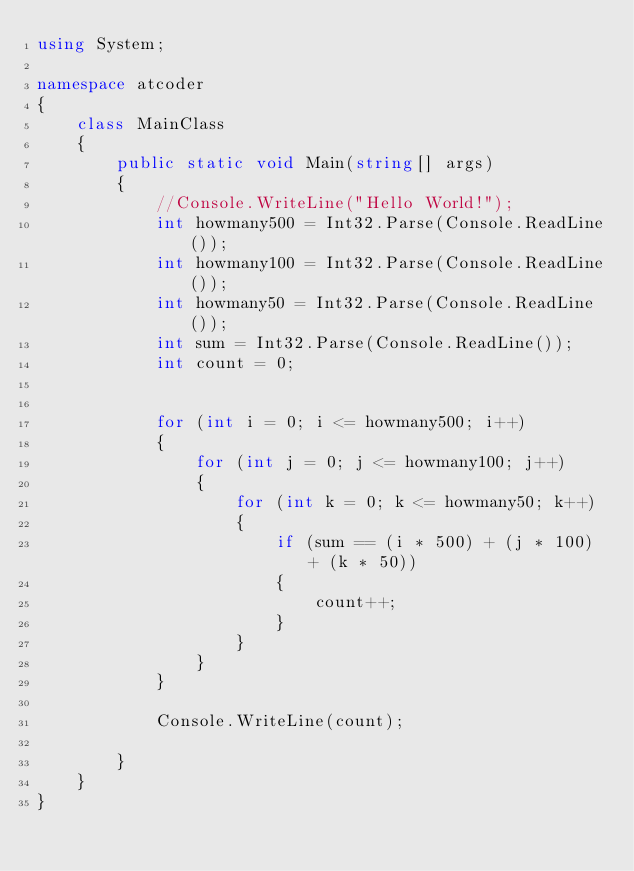<code> <loc_0><loc_0><loc_500><loc_500><_C#_>using System;

namespace atcoder
{
    class MainClass
    {
        public static void Main(string[] args)
        {
            //Console.WriteLine("Hello World!");
            int howmany500 = Int32.Parse(Console.ReadLine());
            int howmany100 = Int32.Parse(Console.ReadLine());
            int howmany50 = Int32.Parse(Console.ReadLine());
            int sum = Int32.Parse(Console.ReadLine());
            int count = 0;


            for (int i = 0; i <= howmany500; i++)
            {
                for (int j = 0; j <= howmany100; j++)
                {
                    for (int k = 0; k <= howmany50; k++)
                    {
                        if (sum == (i * 500) + (j * 100) + (k * 50))
                        {
                            count++;
                        }
                    }
                }
            }

            Console.WriteLine(count);

        }
    }
}
</code> 